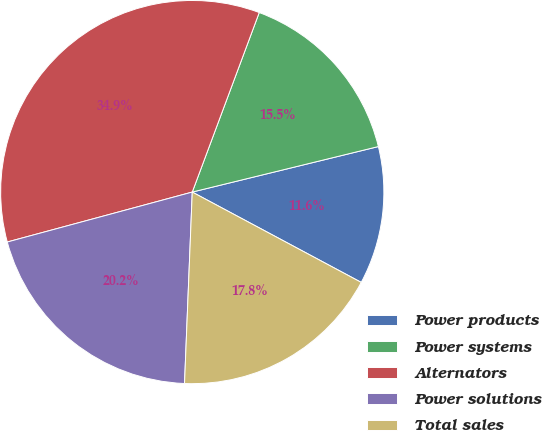Convert chart to OTSL. <chart><loc_0><loc_0><loc_500><loc_500><pie_chart><fcel>Power products<fcel>Power systems<fcel>Alternators<fcel>Power solutions<fcel>Total sales<nl><fcel>11.63%<fcel>15.5%<fcel>34.88%<fcel>20.16%<fcel>17.83%<nl></chart> 